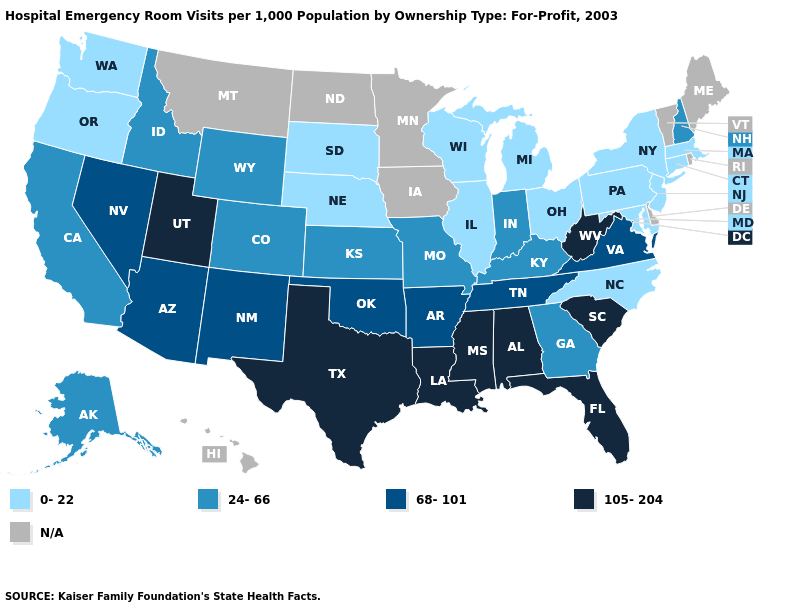Which states hav the highest value in the South?
Give a very brief answer. Alabama, Florida, Louisiana, Mississippi, South Carolina, Texas, West Virginia. What is the value of Colorado?
Quick response, please. 24-66. Among the states that border Utah , which have the highest value?
Answer briefly. Arizona, Nevada, New Mexico. Name the states that have a value in the range 68-101?
Give a very brief answer. Arizona, Arkansas, Nevada, New Mexico, Oklahoma, Tennessee, Virginia. What is the value of Pennsylvania?
Give a very brief answer. 0-22. What is the highest value in the USA?
Short answer required. 105-204. What is the highest value in states that border Pennsylvania?
Write a very short answer. 105-204. Is the legend a continuous bar?
Keep it brief. No. What is the value of Maryland?
Quick response, please. 0-22. Among the states that border Idaho , which have the highest value?
Quick response, please. Utah. What is the highest value in the USA?
Keep it brief. 105-204. Which states have the highest value in the USA?
Quick response, please. Alabama, Florida, Louisiana, Mississippi, South Carolina, Texas, Utah, West Virginia. Does the map have missing data?
Keep it brief. Yes. Is the legend a continuous bar?
Answer briefly. No. 